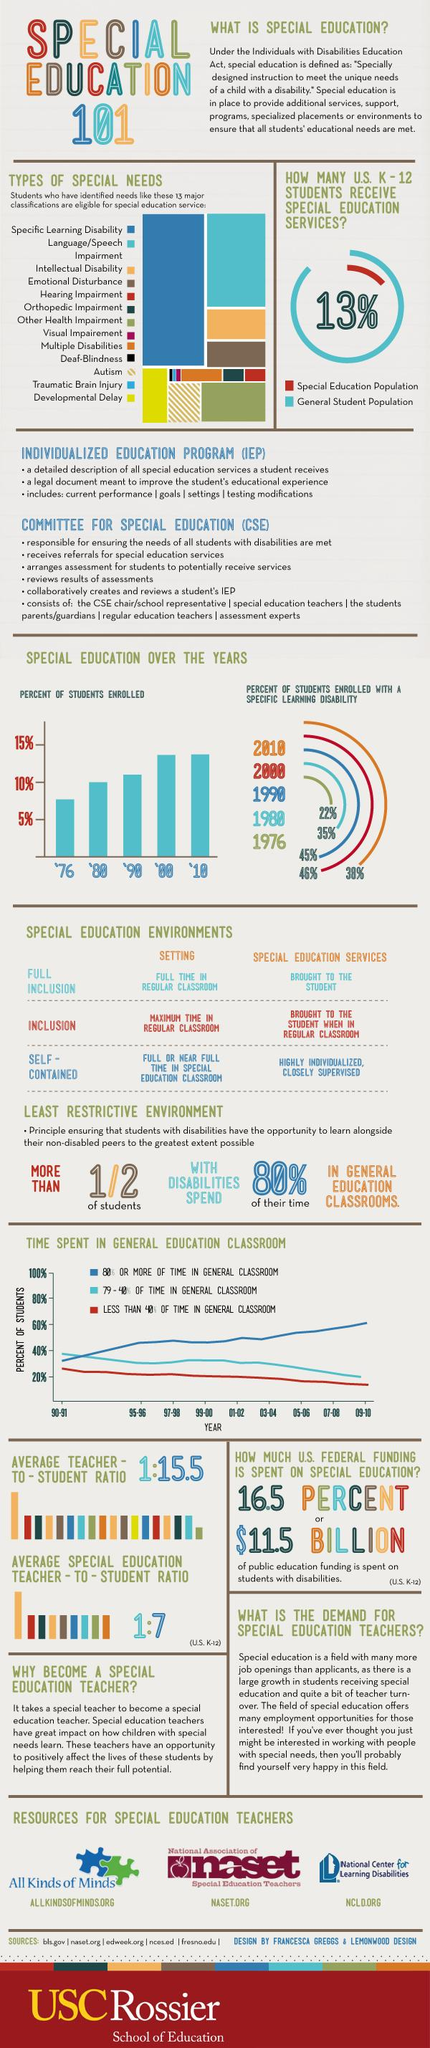Mention a couple of crucial points in this snapshot. In 1976, approximately 5.5% of the enrolled students were present. In every year, an identical percentage of students enrolled. 